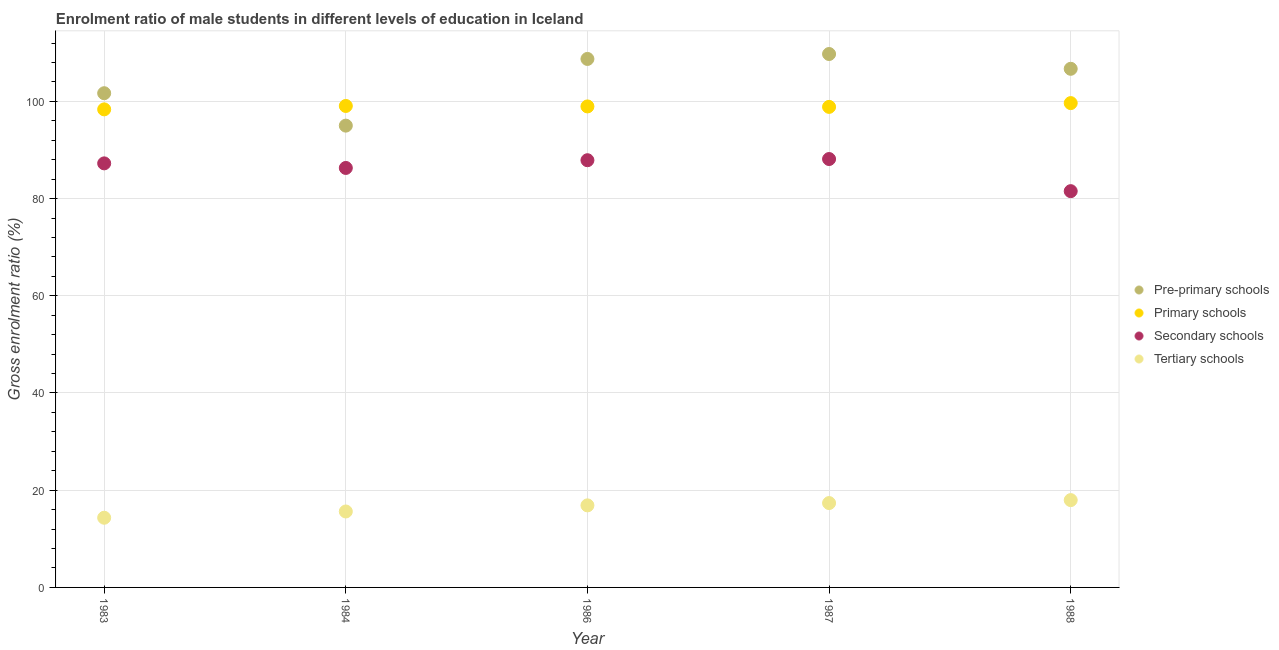How many different coloured dotlines are there?
Make the answer very short. 4. Is the number of dotlines equal to the number of legend labels?
Make the answer very short. Yes. What is the gross enrolment ratio(female) in primary schools in 1986?
Give a very brief answer. 98.95. Across all years, what is the maximum gross enrolment ratio(female) in secondary schools?
Ensure brevity in your answer.  88.13. Across all years, what is the minimum gross enrolment ratio(female) in tertiary schools?
Offer a very short reply. 14.34. In which year was the gross enrolment ratio(female) in secondary schools minimum?
Your answer should be compact. 1988. What is the total gross enrolment ratio(female) in pre-primary schools in the graph?
Make the answer very short. 521.83. What is the difference between the gross enrolment ratio(female) in secondary schools in 1986 and that in 1987?
Offer a very short reply. -0.24. What is the difference between the gross enrolment ratio(female) in pre-primary schools in 1983 and the gross enrolment ratio(female) in primary schools in 1984?
Offer a very short reply. 2.62. What is the average gross enrolment ratio(female) in pre-primary schools per year?
Your answer should be very brief. 104.37. In the year 1988, what is the difference between the gross enrolment ratio(female) in secondary schools and gross enrolment ratio(female) in primary schools?
Keep it short and to the point. -18.11. In how many years, is the gross enrolment ratio(female) in pre-primary schools greater than 60 %?
Provide a short and direct response. 5. What is the ratio of the gross enrolment ratio(female) in secondary schools in 1984 to that in 1986?
Provide a succinct answer. 0.98. Is the gross enrolment ratio(female) in pre-primary schools in 1986 less than that in 1987?
Provide a short and direct response. Yes. Is the difference between the gross enrolment ratio(female) in secondary schools in 1983 and 1986 greater than the difference between the gross enrolment ratio(female) in pre-primary schools in 1983 and 1986?
Ensure brevity in your answer.  Yes. What is the difference between the highest and the second highest gross enrolment ratio(female) in pre-primary schools?
Your answer should be compact. 1.01. What is the difference between the highest and the lowest gross enrolment ratio(female) in tertiary schools?
Offer a very short reply. 3.63. Is the sum of the gross enrolment ratio(female) in tertiary schools in 1983 and 1984 greater than the maximum gross enrolment ratio(female) in primary schools across all years?
Your answer should be very brief. No. Is it the case that in every year, the sum of the gross enrolment ratio(female) in tertiary schools and gross enrolment ratio(female) in pre-primary schools is greater than the sum of gross enrolment ratio(female) in primary schools and gross enrolment ratio(female) in secondary schools?
Offer a very short reply. No. Is the gross enrolment ratio(female) in primary schools strictly less than the gross enrolment ratio(female) in secondary schools over the years?
Provide a succinct answer. No. How many dotlines are there?
Your response must be concise. 4. Where does the legend appear in the graph?
Provide a succinct answer. Center right. How many legend labels are there?
Your response must be concise. 4. What is the title of the graph?
Give a very brief answer. Enrolment ratio of male students in different levels of education in Iceland. What is the label or title of the X-axis?
Your response must be concise. Year. What is the Gross enrolment ratio (%) of Pre-primary schools in 1983?
Offer a terse response. 101.67. What is the Gross enrolment ratio (%) of Primary schools in 1983?
Offer a terse response. 98.35. What is the Gross enrolment ratio (%) in Secondary schools in 1983?
Make the answer very short. 87.24. What is the Gross enrolment ratio (%) in Tertiary schools in 1983?
Offer a terse response. 14.34. What is the Gross enrolment ratio (%) in Pre-primary schools in 1984?
Keep it short and to the point. 95. What is the Gross enrolment ratio (%) of Primary schools in 1984?
Provide a succinct answer. 99.05. What is the Gross enrolment ratio (%) of Secondary schools in 1984?
Offer a terse response. 86.3. What is the Gross enrolment ratio (%) of Tertiary schools in 1984?
Offer a very short reply. 15.62. What is the Gross enrolment ratio (%) of Pre-primary schools in 1986?
Your answer should be compact. 108.72. What is the Gross enrolment ratio (%) of Primary schools in 1986?
Ensure brevity in your answer.  98.95. What is the Gross enrolment ratio (%) in Secondary schools in 1986?
Provide a succinct answer. 87.89. What is the Gross enrolment ratio (%) in Tertiary schools in 1986?
Your response must be concise. 16.88. What is the Gross enrolment ratio (%) in Pre-primary schools in 1987?
Provide a succinct answer. 109.74. What is the Gross enrolment ratio (%) of Primary schools in 1987?
Your response must be concise. 98.86. What is the Gross enrolment ratio (%) in Secondary schools in 1987?
Your answer should be very brief. 88.13. What is the Gross enrolment ratio (%) in Tertiary schools in 1987?
Ensure brevity in your answer.  17.36. What is the Gross enrolment ratio (%) in Pre-primary schools in 1988?
Keep it short and to the point. 106.69. What is the Gross enrolment ratio (%) of Primary schools in 1988?
Offer a very short reply. 99.64. What is the Gross enrolment ratio (%) in Secondary schools in 1988?
Offer a terse response. 81.52. What is the Gross enrolment ratio (%) of Tertiary schools in 1988?
Give a very brief answer. 17.96. Across all years, what is the maximum Gross enrolment ratio (%) in Pre-primary schools?
Your answer should be compact. 109.74. Across all years, what is the maximum Gross enrolment ratio (%) of Primary schools?
Provide a short and direct response. 99.64. Across all years, what is the maximum Gross enrolment ratio (%) of Secondary schools?
Your answer should be compact. 88.13. Across all years, what is the maximum Gross enrolment ratio (%) in Tertiary schools?
Provide a succinct answer. 17.96. Across all years, what is the minimum Gross enrolment ratio (%) of Pre-primary schools?
Provide a succinct answer. 95. Across all years, what is the minimum Gross enrolment ratio (%) in Primary schools?
Offer a very short reply. 98.35. Across all years, what is the minimum Gross enrolment ratio (%) in Secondary schools?
Your answer should be very brief. 81.52. Across all years, what is the minimum Gross enrolment ratio (%) of Tertiary schools?
Keep it short and to the point. 14.34. What is the total Gross enrolment ratio (%) of Pre-primary schools in the graph?
Provide a short and direct response. 521.83. What is the total Gross enrolment ratio (%) in Primary schools in the graph?
Provide a succinct answer. 494.85. What is the total Gross enrolment ratio (%) in Secondary schools in the graph?
Provide a short and direct response. 431.08. What is the total Gross enrolment ratio (%) of Tertiary schools in the graph?
Offer a terse response. 82.16. What is the difference between the Gross enrolment ratio (%) of Pre-primary schools in 1983 and that in 1984?
Your response must be concise. 6.67. What is the difference between the Gross enrolment ratio (%) in Primary schools in 1983 and that in 1984?
Your answer should be very brief. -0.7. What is the difference between the Gross enrolment ratio (%) of Secondary schools in 1983 and that in 1984?
Give a very brief answer. 0.94. What is the difference between the Gross enrolment ratio (%) of Tertiary schools in 1983 and that in 1984?
Keep it short and to the point. -1.29. What is the difference between the Gross enrolment ratio (%) of Pre-primary schools in 1983 and that in 1986?
Offer a terse response. -7.05. What is the difference between the Gross enrolment ratio (%) of Primary schools in 1983 and that in 1986?
Give a very brief answer. -0.61. What is the difference between the Gross enrolment ratio (%) of Secondary schools in 1983 and that in 1986?
Offer a very short reply. -0.65. What is the difference between the Gross enrolment ratio (%) of Tertiary schools in 1983 and that in 1986?
Ensure brevity in your answer.  -2.54. What is the difference between the Gross enrolment ratio (%) in Pre-primary schools in 1983 and that in 1987?
Provide a short and direct response. -8.07. What is the difference between the Gross enrolment ratio (%) in Primary schools in 1983 and that in 1987?
Offer a terse response. -0.51. What is the difference between the Gross enrolment ratio (%) in Secondary schools in 1983 and that in 1987?
Make the answer very short. -0.89. What is the difference between the Gross enrolment ratio (%) in Tertiary schools in 1983 and that in 1987?
Ensure brevity in your answer.  -3.02. What is the difference between the Gross enrolment ratio (%) of Pre-primary schools in 1983 and that in 1988?
Offer a very short reply. -5.02. What is the difference between the Gross enrolment ratio (%) in Primary schools in 1983 and that in 1988?
Offer a terse response. -1.29. What is the difference between the Gross enrolment ratio (%) in Secondary schools in 1983 and that in 1988?
Ensure brevity in your answer.  5.72. What is the difference between the Gross enrolment ratio (%) of Tertiary schools in 1983 and that in 1988?
Offer a very short reply. -3.63. What is the difference between the Gross enrolment ratio (%) in Pre-primary schools in 1984 and that in 1986?
Offer a very short reply. -13.72. What is the difference between the Gross enrolment ratio (%) of Primary schools in 1984 and that in 1986?
Make the answer very short. 0.1. What is the difference between the Gross enrolment ratio (%) in Secondary schools in 1984 and that in 1986?
Keep it short and to the point. -1.59. What is the difference between the Gross enrolment ratio (%) in Tertiary schools in 1984 and that in 1986?
Make the answer very short. -1.26. What is the difference between the Gross enrolment ratio (%) in Pre-primary schools in 1984 and that in 1987?
Offer a terse response. -14.73. What is the difference between the Gross enrolment ratio (%) of Primary schools in 1984 and that in 1987?
Your answer should be very brief. 0.19. What is the difference between the Gross enrolment ratio (%) in Secondary schools in 1984 and that in 1987?
Provide a short and direct response. -1.83. What is the difference between the Gross enrolment ratio (%) of Tertiary schools in 1984 and that in 1987?
Make the answer very short. -1.73. What is the difference between the Gross enrolment ratio (%) in Pre-primary schools in 1984 and that in 1988?
Your answer should be very brief. -11.69. What is the difference between the Gross enrolment ratio (%) of Primary schools in 1984 and that in 1988?
Offer a terse response. -0.59. What is the difference between the Gross enrolment ratio (%) of Secondary schools in 1984 and that in 1988?
Offer a very short reply. 4.77. What is the difference between the Gross enrolment ratio (%) in Tertiary schools in 1984 and that in 1988?
Provide a succinct answer. -2.34. What is the difference between the Gross enrolment ratio (%) in Pre-primary schools in 1986 and that in 1987?
Your response must be concise. -1.01. What is the difference between the Gross enrolment ratio (%) of Primary schools in 1986 and that in 1987?
Keep it short and to the point. 0.1. What is the difference between the Gross enrolment ratio (%) in Secondary schools in 1986 and that in 1987?
Your answer should be very brief. -0.24. What is the difference between the Gross enrolment ratio (%) of Tertiary schools in 1986 and that in 1987?
Ensure brevity in your answer.  -0.47. What is the difference between the Gross enrolment ratio (%) of Pre-primary schools in 1986 and that in 1988?
Ensure brevity in your answer.  2.03. What is the difference between the Gross enrolment ratio (%) in Primary schools in 1986 and that in 1988?
Your response must be concise. -0.68. What is the difference between the Gross enrolment ratio (%) of Secondary schools in 1986 and that in 1988?
Give a very brief answer. 6.37. What is the difference between the Gross enrolment ratio (%) in Tertiary schools in 1986 and that in 1988?
Your answer should be compact. -1.08. What is the difference between the Gross enrolment ratio (%) of Pre-primary schools in 1987 and that in 1988?
Ensure brevity in your answer.  3.04. What is the difference between the Gross enrolment ratio (%) of Primary schools in 1987 and that in 1988?
Ensure brevity in your answer.  -0.78. What is the difference between the Gross enrolment ratio (%) in Secondary schools in 1987 and that in 1988?
Ensure brevity in your answer.  6.61. What is the difference between the Gross enrolment ratio (%) in Tertiary schools in 1987 and that in 1988?
Your answer should be compact. -0.61. What is the difference between the Gross enrolment ratio (%) of Pre-primary schools in 1983 and the Gross enrolment ratio (%) of Primary schools in 1984?
Ensure brevity in your answer.  2.62. What is the difference between the Gross enrolment ratio (%) in Pre-primary schools in 1983 and the Gross enrolment ratio (%) in Secondary schools in 1984?
Make the answer very short. 15.38. What is the difference between the Gross enrolment ratio (%) of Pre-primary schools in 1983 and the Gross enrolment ratio (%) of Tertiary schools in 1984?
Offer a very short reply. 86.05. What is the difference between the Gross enrolment ratio (%) in Primary schools in 1983 and the Gross enrolment ratio (%) in Secondary schools in 1984?
Offer a terse response. 12.05. What is the difference between the Gross enrolment ratio (%) in Primary schools in 1983 and the Gross enrolment ratio (%) in Tertiary schools in 1984?
Your answer should be very brief. 82.73. What is the difference between the Gross enrolment ratio (%) of Secondary schools in 1983 and the Gross enrolment ratio (%) of Tertiary schools in 1984?
Ensure brevity in your answer.  71.61. What is the difference between the Gross enrolment ratio (%) of Pre-primary schools in 1983 and the Gross enrolment ratio (%) of Primary schools in 1986?
Your answer should be compact. 2.72. What is the difference between the Gross enrolment ratio (%) of Pre-primary schools in 1983 and the Gross enrolment ratio (%) of Secondary schools in 1986?
Your answer should be very brief. 13.78. What is the difference between the Gross enrolment ratio (%) of Pre-primary schools in 1983 and the Gross enrolment ratio (%) of Tertiary schools in 1986?
Ensure brevity in your answer.  84.79. What is the difference between the Gross enrolment ratio (%) of Primary schools in 1983 and the Gross enrolment ratio (%) of Secondary schools in 1986?
Give a very brief answer. 10.46. What is the difference between the Gross enrolment ratio (%) of Primary schools in 1983 and the Gross enrolment ratio (%) of Tertiary schools in 1986?
Provide a succinct answer. 81.47. What is the difference between the Gross enrolment ratio (%) of Secondary schools in 1983 and the Gross enrolment ratio (%) of Tertiary schools in 1986?
Ensure brevity in your answer.  70.36. What is the difference between the Gross enrolment ratio (%) of Pre-primary schools in 1983 and the Gross enrolment ratio (%) of Primary schools in 1987?
Provide a succinct answer. 2.81. What is the difference between the Gross enrolment ratio (%) in Pre-primary schools in 1983 and the Gross enrolment ratio (%) in Secondary schools in 1987?
Provide a succinct answer. 13.54. What is the difference between the Gross enrolment ratio (%) in Pre-primary schools in 1983 and the Gross enrolment ratio (%) in Tertiary schools in 1987?
Ensure brevity in your answer.  84.32. What is the difference between the Gross enrolment ratio (%) in Primary schools in 1983 and the Gross enrolment ratio (%) in Secondary schools in 1987?
Keep it short and to the point. 10.22. What is the difference between the Gross enrolment ratio (%) in Primary schools in 1983 and the Gross enrolment ratio (%) in Tertiary schools in 1987?
Offer a very short reply. 80.99. What is the difference between the Gross enrolment ratio (%) of Secondary schools in 1983 and the Gross enrolment ratio (%) of Tertiary schools in 1987?
Your answer should be compact. 69.88. What is the difference between the Gross enrolment ratio (%) in Pre-primary schools in 1983 and the Gross enrolment ratio (%) in Primary schools in 1988?
Your answer should be compact. 2.03. What is the difference between the Gross enrolment ratio (%) of Pre-primary schools in 1983 and the Gross enrolment ratio (%) of Secondary schools in 1988?
Keep it short and to the point. 20.15. What is the difference between the Gross enrolment ratio (%) of Pre-primary schools in 1983 and the Gross enrolment ratio (%) of Tertiary schools in 1988?
Give a very brief answer. 83.71. What is the difference between the Gross enrolment ratio (%) of Primary schools in 1983 and the Gross enrolment ratio (%) of Secondary schools in 1988?
Make the answer very short. 16.83. What is the difference between the Gross enrolment ratio (%) of Primary schools in 1983 and the Gross enrolment ratio (%) of Tertiary schools in 1988?
Ensure brevity in your answer.  80.38. What is the difference between the Gross enrolment ratio (%) of Secondary schools in 1983 and the Gross enrolment ratio (%) of Tertiary schools in 1988?
Offer a terse response. 69.27. What is the difference between the Gross enrolment ratio (%) in Pre-primary schools in 1984 and the Gross enrolment ratio (%) in Primary schools in 1986?
Make the answer very short. -3.95. What is the difference between the Gross enrolment ratio (%) of Pre-primary schools in 1984 and the Gross enrolment ratio (%) of Secondary schools in 1986?
Provide a short and direct response. 7.11. What is the difference between the Gross enrolment ratio (%) of Pre-primary schools in 1984 and the Gross enrolment ratio (%) of Tertiary schools in 1986?
Ensure brevity in your answer.  78.12. What is the difference between the Gross enrolment ratio (%) of Primary schools in 1984 and the Gross enrolment ratio (%) of Secondary schools in 1986?
Your answer should be compact. 11.16. What is the difference between the Gross enrolment ratio (%) of Primary schools in 1984 and the Gross enrolment ratio (%) of Tertiary schools in 1986?
Ensure brevity in your answer.  82.17. What is the difference between the Gross enrolment ratio (%) of Secondary schools in 1984 and the Gross enrolment ratio (%) of Tertiary schools in 1986?
Ensure brevity in your answer.  69.42. What is the difference between the Gross enrolment ratio (%) of Pre-primary schools in 1984 and the Gross enrolment ratio (%) of Primary schools in 1987?
Your answer should be very brief. -3.86. What is the difference between the Gross enrolment ratio (%) of Pre-primary schools in 1984 and the Gross enrolment ratio (%) of Secondary schools in 1987?
Your answer should be compact. 6.87. What is the difference between the Gross enrolment ratio (%) in Pre-primary schools in 1984 and the Gross enrolment ratio (%) in Tertiary schools in 1987?
Provide a short and direct response. 77.65. What is the difference between the Gross enrolment ratio (%) of Primary schools in 1984 and the Gross enrolment ratio (%) of Secondary schools in 1987?
Your answer should be compact. 10.92. What is the difference between the Gross enrolment ratio (%) of Primary schools in 1984 and the Gross enrolment ratio (%) of Tertiary schools in 1987?
Offer a terse response. 81.7. What is the difference between the Gross enrolment ratio (%) in Secondary schools in 1984 and the Gross enrolment ratio (%) in Tertiary schools in 1987?
Your answer should be very brief. 68.94. What is the difference between the Gross enrolment ratio (%) of Pre-primary schools in 1984 and the Gross enrolment ratio (%) of Primary schools in 1988?
Offer a terse response. -4.63. What is the difference between the Gross enrolment ratio (%) in Pre-primary schools in 1984 and the Gross enrolment ratio (%) in Secondary schools in 1988?
Your response must be concise. 13.48. What is the difference between the Gross enrolment ratio (%) of Pre-primary schools in 1984 and the Gross enrolment ratio (%) of Tertiary schools in 1988?
Your answer should be compact. 77.04. What is the difference between the Gross enrolment ratio (%) of Primary schools in 1984 and the Gross enrolment ratio (%) of Secondary schools in 1988?
Provide a short and direct response. 17.53. What is the difference between the Gross enrolment ratio (%) in Primary schools in 1984 and the Gross enrolment ratio (%) in Tertiary schools in 1988?
Give a very brief answer. 81.09. What is the difference between the Gross enrolment ratio (%) in Secondary schools in 1984 and the Gross enrolment ratio (%) in Tertiary schools in 1988?
Give a very brief answer. 68.33. What is the difference between the Gross enrolment ratio (%) of Pre-primary schools in 1986 and the Gross enrolment ratio (%) of Primary schools in 1987?
Offer a very short reply. 9.86. What is the difference between the Gross enrolment ratio (%) in Pre-primary schools in 1986 and the Gross enrolment ratio (%) in Secondary schools in 1987?
Offer a terse response. 20.59. What is the difference between the Gross enrolment ratio (%) of Pre-primary schools in 1986 and the Gross enrolment ratio (%) of Tertiary schools in 1987?
Your answer should be compact. 91.37. What is the difference between the Gross enrolment ratio (%) of Primary schools in 1986 and the Gross enrolment ratio (%) of Secondary schools in 1987?
Provide a succinct answer. 10.82. What is the difference between the Gross enrolment ratio (%) in Primary schools in 1986 and the Gross enrolment ratio (%) in Tertiary schools in 1987?
Ensure brevity in your answer.  81.6. What is the difference between the Gross enrolment ratio (%) in Secondary schools in 1986 and the Gross enrolment ratio (%) in Tertiary schools in 1987?
Ensure brevity in your answer.  70.53. What is the difference between the Gross enrolment ratio (%) of Pre-primary schools in 1986 and the Gross enrolment ratio (%) of Primary schools in 1988?
Provide a succinct answer. 9.09. What is the difference between the Gross enrolment ratio (%) of Pre-primary schools in 1986 and the Gross enrolment ratio (%) of Secondary schools in 1988?
Provide a succinct answer. 27.2. What is the difference between the Gross enrolment ratio (%) of Pre-primary schools in 1986 and the Gross enrolment ratio (%) of Tertiary schools in 1988?
Offer a terse response. 90.76. What is the difference between the Gross enrolment ratio (%) of Primary schools in 1986 and the Gross enrolment ratio (%) of Secondary schools in 1988?
Give a very brief answer. 17.43. What is the difference between the Gross enrolment ratio (%) of Primary schools in 1986 and the Gross enrolment ratio (%) of Tertiary schools in 1988?
Provide a succinct answer. 80.99. What is the difference between the Gross enrolment ratio (%) in Secondary schools in 1986 and the Gross enrolment ratio (%) in Tertiary schools in 1988?
Provide a succinct answer. 69.92. What is the difference between the Gross enrolment ratio (%) of Pre-primary schools in 1987 and the Gross enrolment ratio (%) of Primary schools in 1988?
Make the answer very short. 10.1. What is the difference between the Gross enrolment ratio (%) of Pre-primary schools in 1987 and the Gross enrolment ratio (%) of Secondary schools in 1988?
Offer a very short reply. 28.21. What is the difference between the Gross enrolment ratio (%) in Pre-primary schools in 1987 and the Gross enrolment ratio (%) in Tertiary schools in 1988?
Provide a succinct answer. 91.77. What is the difference between the Gross enrolment ratio (%) of Primary schools in 1987 and the Gross enrolment ratio (%) of Secondary schools in 1988?
Offer a terse response. 17.34. What is the difference between the Gross enrolment ratio (%) in Primary schools in 1987 and the Gross enrolment ratio (%) in Tertiary schools in 1988?
Your answer should be very brief. 80.89. What is the difference between the Gross enrolment ratio (%) in Secondary schools in 1987 and the Gross enrolment ratio (%) in Tertiary schools in 1988?
Your answer should be compact. 70.17. What is the average Gross enrolment ratio (%) of Pre-primary schools per year?
Your response must be concise. 104.37. What is the average Gross enrolment ratio (%) in Primary schools per year?
Offer a very short reply. 98.97. What is the average Gross enrolment ratio (%) of Secondary schools per year?
Keep it short and to the point. 86.22. What is the average Gross enrolment ratio (%) in Tertiary schools per year?
Give a very brief answer. 16.43. In the year 1983, what is the difference between the Gross enrolment ratio (%) of Pre-primary schools and Gross enrolment ratio (%) of Primary schools?
Provide a succinct answer. 3.32. In the year 1983, what is the difference between the Gross enrolment ratio (%) in Pre-primary schools and Gross enrolment ratio (%) in Secondary schools?
Give a very brief answer. 14.43. In the year 1983, what is the difference between the Gross enrolment ratio (%) of Pre-primary schools and Gross enrolment ratio (%) of Tertiary schools?
Your answer should be very brief. 87.33. In the year 1983, what is the difference between the Gross enrolment ratio (%) in Primary schools and Gross enrolment ratio (%) in Secondary schools?
Your answer should be compact. 11.11. In the year 1983, what is the difference between the Gross enrolment ratio (%) in Primary schools and Gross enrolment ratio (%) in Tertiary schools?
Your answer should be compact. 84.01. In the year 1983, what is the difference between the Gross enrolment ratio (%) of Secondary schools and Gross enrolment ratio (%) of Tertiary schools?
Offer a very short reply. 72.9. In the year 1984, what is the difference between the Gross enrolment ratio (%) of Pre-primary schools and Gross enrolment ratio (%) of Primary schools?
Provide a short and direct response. -4.05. In the year 1984, what is the difference between the Gross enrolment ratio (%) in Pre-primary schools and Gross enrolment ratio (%) in Secondary schools?
Your response must be concise. 8.71. In the year 1984, what is the difference between the Gross enrolment ratio (%) of Pre-primary schools and Gross enrolment ratio (%) of Tertiary schools?
Your response must be concise. 79.38. In the year 1984, what is the difference between the Gross enrolment ratio (%) of Primary schools and Gross enrolment ratio (%) of Secondary schools?
Offer a terse response. 12.75. In the year 1984, what is the difference between the Gross enrolment ratio (%) in Primary schools and Gross enrolment ratio (%) in Tertiary schools?
Give a very brief answer. 83.43. In the year 1984, what is the difference between the Gross enrolment ratio (%) in Secondary schools and Gross enrolment ratio (%) in Tertiary schools?
Your answer should be very brief. 70.67. In the year 1986, what is the difference between the Gross enrolment ratio (%) in Pre-primary schools and Gross enrolment ratio (%) in Primary schools?
Your answer should be compact. 9.77. In the year 1986, what is the difference between the Gross enrolment ratio (%) in Pre-primary schools and Gross enrolment ratio (%) in Secondary schools?
Offer a very short reply. 20.83. In the year 1986, what is the difference between the Gross enrolment ratio (%) of Pre-primary schools and Gross enrolment ratio (%) of Tertiary schools?
Provide a short and direct response. 91.84. In the year 1986, what is the difference between the Gross enrolment ratio (%) in Primary schools and Gross enrolment ratio (%) in Secondary schools?
Provide a short and direct response. 11.07. In the year 1986, what is the difference between the Gross enrolment ratio (%) in Primary schools and Gross enrolment ratio (%) in Tertiary schools?
Offer a very short reply. 82.07. In the year 1986, what is the difference between the Gross enrolment ratio (%) in Secondary schools and Gross enrolment ratio (%) in Tertiary schools?
Your answer should be very brief. 71.01. In the year 1987, what is the difference between the Gross enrolment ratio (%) of Pre-primary schools and Gross enrolment ratio (%) of Primary schools?
Offer a terse response. 10.88. In the year 1987, what is the difference between the Gross enrolment ratio (%) in Pre-primary schools and Gross enrolment ratio (%) in Secondary schools?
Give a very brief answer. 21.61. In the year 1987, what is the difference between the Gross enrolment ratio (%) of Pre-primary schools and Gross enrolment ratio (%) of Tertiary schools?
Give a very brief answer. 92.38. In the year 1987, what is the difference between the Gross enrolment ratio (%) of Primary schools and Gross enrolment ratio (%) of Secondary schools?
Provide a short and direct response. 10.73. In the year 1987, what is the difference between the Gross enrolment ratio (%) in Primary schools and Gross enrolment ratio (%) in Tertiary schools?
Keep it short and to the point. 81.5. In the year 1987, what is the difference between the Gross enrolment ratio (%) of Secondary schools and Gross enrolment ratio (%) of Tertiary schools?
Make the answer very short. 70.78. In the year 1988, what is the difference between the Gross enrolment ratio (%) of Pre-primary schools and Gross enrolment ratio (%) of Primary schools?
Give a very brief answer. 7.06. In the year 1988, what is the difference between the Gross enrolment ratio (%) in Pre-primary schools and Gross enrolment ratio (%) in Secondary schools?
Give a very brief answer. 25.17. In the year 1988, what is the difference between the Gross enrolment ratio (%) in Pre-primary schools and Gross enrolment ratio (%) in Tertiary schools?
Provide a short and direct response. 88.73. In the year 1988, what is the difference between the Gross enrolment ratio (%) in Primary schools and Gross enrolment ratio (%) in Secondary schools?
Ensure brevity in your answer.  18.11. In the year 1988, what is the difference between the Gross enrolment ratio (%) of Primary schools and Gross enrolment ratio (%) of Tertiary schools?
Give a very brief answer. 81.67. In the year 1988, what is the difference between the Gross enrolment ratio (%) of Secondary schools and Gross enrolment ratio (%) of Tertiary schools?
Give a very brief answer. 63.56. What is the ratio of the Gross enrolment ratio (%) in Pre-primary schools in 1983 to that in 1984?
Your answer should be very brief. 1.07. What is the ratio of the Gross enrolment ratio (%) in Secondary schools in 1983 to that in 1984?
Give a very brief answer. 1.01. What is the ratio of the Gross enrolment ratio (%) in Tertiary schools in 1983 to that in 1984?
Provide a succinct answer. 0.92. What is the ratio of the Gross enrolment ratio (%) in Pre-primary schools in 1983 to that in 1986?
Your answer should be compact. 0.94. What is the ratio of the Gross enrolment ratio (%) of Tertiary schools in 1983 to that in 1986?
Your answer should be compact. 0.85. What is the ratio of the Gross enrolment ratio (%) in Pre-primary schools in 1983 to that in 1987?
Ensure brevity in your answer.  0.93. What is the ratio of the Gross enrolment ratio (%) in Secondary schools in 1983 to that in 1987?
Your answer should be very brief. 0.99. What is the ratio of the Gross enrolment ratio (%) of Tertiary schools in 1983 to that in 1987?
Offer a very short reply. 0.83. What is the ratio of the Gross enrolment ratio (%) of Pre-primary schools in 1983 to that in 1988?
Your answer should be very brief. 0.95. What is the ratio of the Gross enrolment ratio (%) in Primary schools in 1983 to that in 1988?
Offer a terse response. 0.99. What is the ratio of the Gross enrolment ratio (%) in Secondary schools in 1983 to that in 1988?
Make the answer very short. 1.07. What is the ratio of the Gross enrolment ratio (%) of Tertiary schools in 1983 to that in 1988?
Make the answer very short. 0.8. What is the ratio of the Gross enrolment ratio (%) of Pre-primary schools in 1984 to that in 1986?
Your response must be concise. 0.87. What is the ratio of the Gross enrolment ratio (%) in Secondary schools in 1984 to that in 1986?
Your answer should be compact. 0.98. What is the ratio of the Gross enrolment ratio (%) in Tertiary schools in 1984 to that in 1986?
Give a very brief answer. 0.93. What is the ratio of the Gross enrolment ratio (%) of Pre-primary schools in 1984 to that in 1987?
Your answer should be very brief. 0.87. What is the ratio of the Gross enrolment ratio (%) in Primary schools in 1984 to that in 1987?
Offer a very short reply. 1. What is the ratio of the Gross enrolment ratio (%) in Secondary schools in 1984 to that in 1987?
Provide a succinct answer. 0.98. What is the ratio of the Gross enrolment ratio (%) of Tertiary schools in 1984 to that in 1987?
Provide a short and direct response. 0.9. What is the ratio of the Gross enrolment ratio (%) in Pre-primary schools in 1984 to that in 1988?
Make the answer very short. 0.89. What is the ratio of the Gross enrolment ratio (%) of Secondary schools in 1984 to that in 1988?
Keep it short and to the point. 1.06. What is the ratio of the Gross enrolment ratio (%) of Tertiary schools in 1984 to that in 1988?
Keep it short and to the point. 0.87. What is the ratio of the Gross enrolment ratio (%) of Primary schools in 1986 to that in 1987?
Offer a terse response. 1. What is the ratio of the Gross enrolment ratio (%) in Tertiary schools in 1986 to that in 1987?
Keep it short and to the point. 0.97. What is the ratio of the Gross enrolment ratio (%) of Primary schools in 1986 to that in 1988?
Provide a short and direct response. 0.99. What is the ratio of the Gross enrolment ratio (%) of Secondary schools in 1986 to that in 1988?
Ensure brevity in your answer.  1.08. What is the ratio of the Gross enrolment ratio (%) of Tertiary schools in 1986 to that in 1988?
Offer a very short reply. 0.94. What is the ratio of the Gross enrolment ratio (%) of Pre-primary schools in 1987 to that in 1988?
Make the answer very short. 1.03. What is the ratio of the Gross enrolment ratio (%) of Primary schools in 1987 to that in 1988?
Provide a succinct answer. 0.99. What is the ratio of the Gross enrolment ratio (%) in Secondary schools in 1987 to that in 1988?
Ensure brevity in your answer.  1.08. What is the ratio of the Gross enrolment ratio (%) in Tertiary schools in 1987 to that in 1988?
Give a very brief answer. 0.97. What is the difference between the highest and the second highest Gross enrolment ratio (%) in Pre-primary schools?
Your answer should be compact. 1.01. What is the difference between the highest and the second highest Gross enrolment ratio (%) in Primary schools?
Keep it short and to the point. 0.59. What is the difference between the highest and the second highest Gross enrolment ratio (%) in Secondary schools?
Make the answer very short. 0.24. What is the difference between the highest and the second highest Gross enrolment ratio (%) in Tertiary schools?
Your response must be concise. 0.61. What is the difference between the highest and the lowest Gross enrolment ratio (%) of Pre-primary schools?
Your answer should be very brief. 14.73. What is the difference between the highest and the lowest Gross enrolment ratio (%) of Primary schools?
Your answer should be very brief. 1.29. What is the difference between the highest and the lowest Gross enrolment ratio (%) in Secondary schools?
Provide a short and direct response. 6.61. What is the difference between the highest and the lowest Gross enrolment ratio (%) in Tertiary schools?
Offer a terse response. 3.63. 